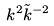<formula> <loc_0><loc_0><loc_500><loc_500>k ^ { 2 } \tilde { k } ^ { - 2 }</formula> 